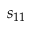Convert formula to latex. <formula><loc_0><loc_0><loc_500><loc_500>s _ { 1 1 }</formula> 